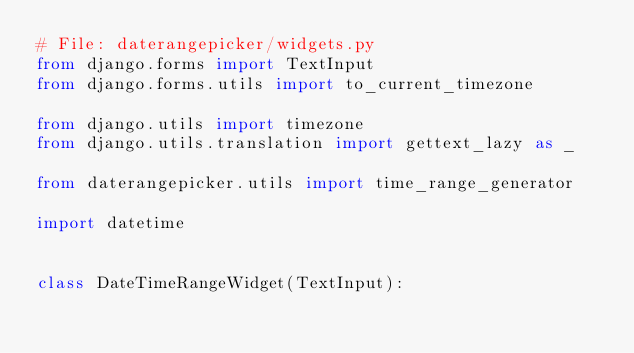<code> <loc_0><loc_0><loc_500><loc_500><_Python_># File: daterangepicker/widgets.py
from django.forms import TextInput
from django.forms.utils import to_current_timezone

from django.utils import timezone
from django.utils.translation import gettext_lazy as _

from daterangepicker.utils import time_range_generator

import datetime


class DateTimeRangeWidget(TextInput):</code> 